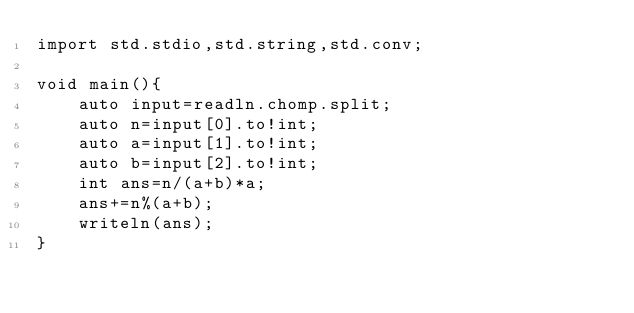Convert code to text. <code><loc_0><loc_0><loc_500><loc_500><_D_>import std.stdio,std.string,std.conv;

void main(){
    auto input=readln.chomp.split;
    auto n=input[0].to!int;
    auto a=input[1].to!int;
    auto b=input[2].to!int;
    int ans=n/(a+b)*a;
    ans+=n%(a+b);
    writeln(ans);
}</code> 